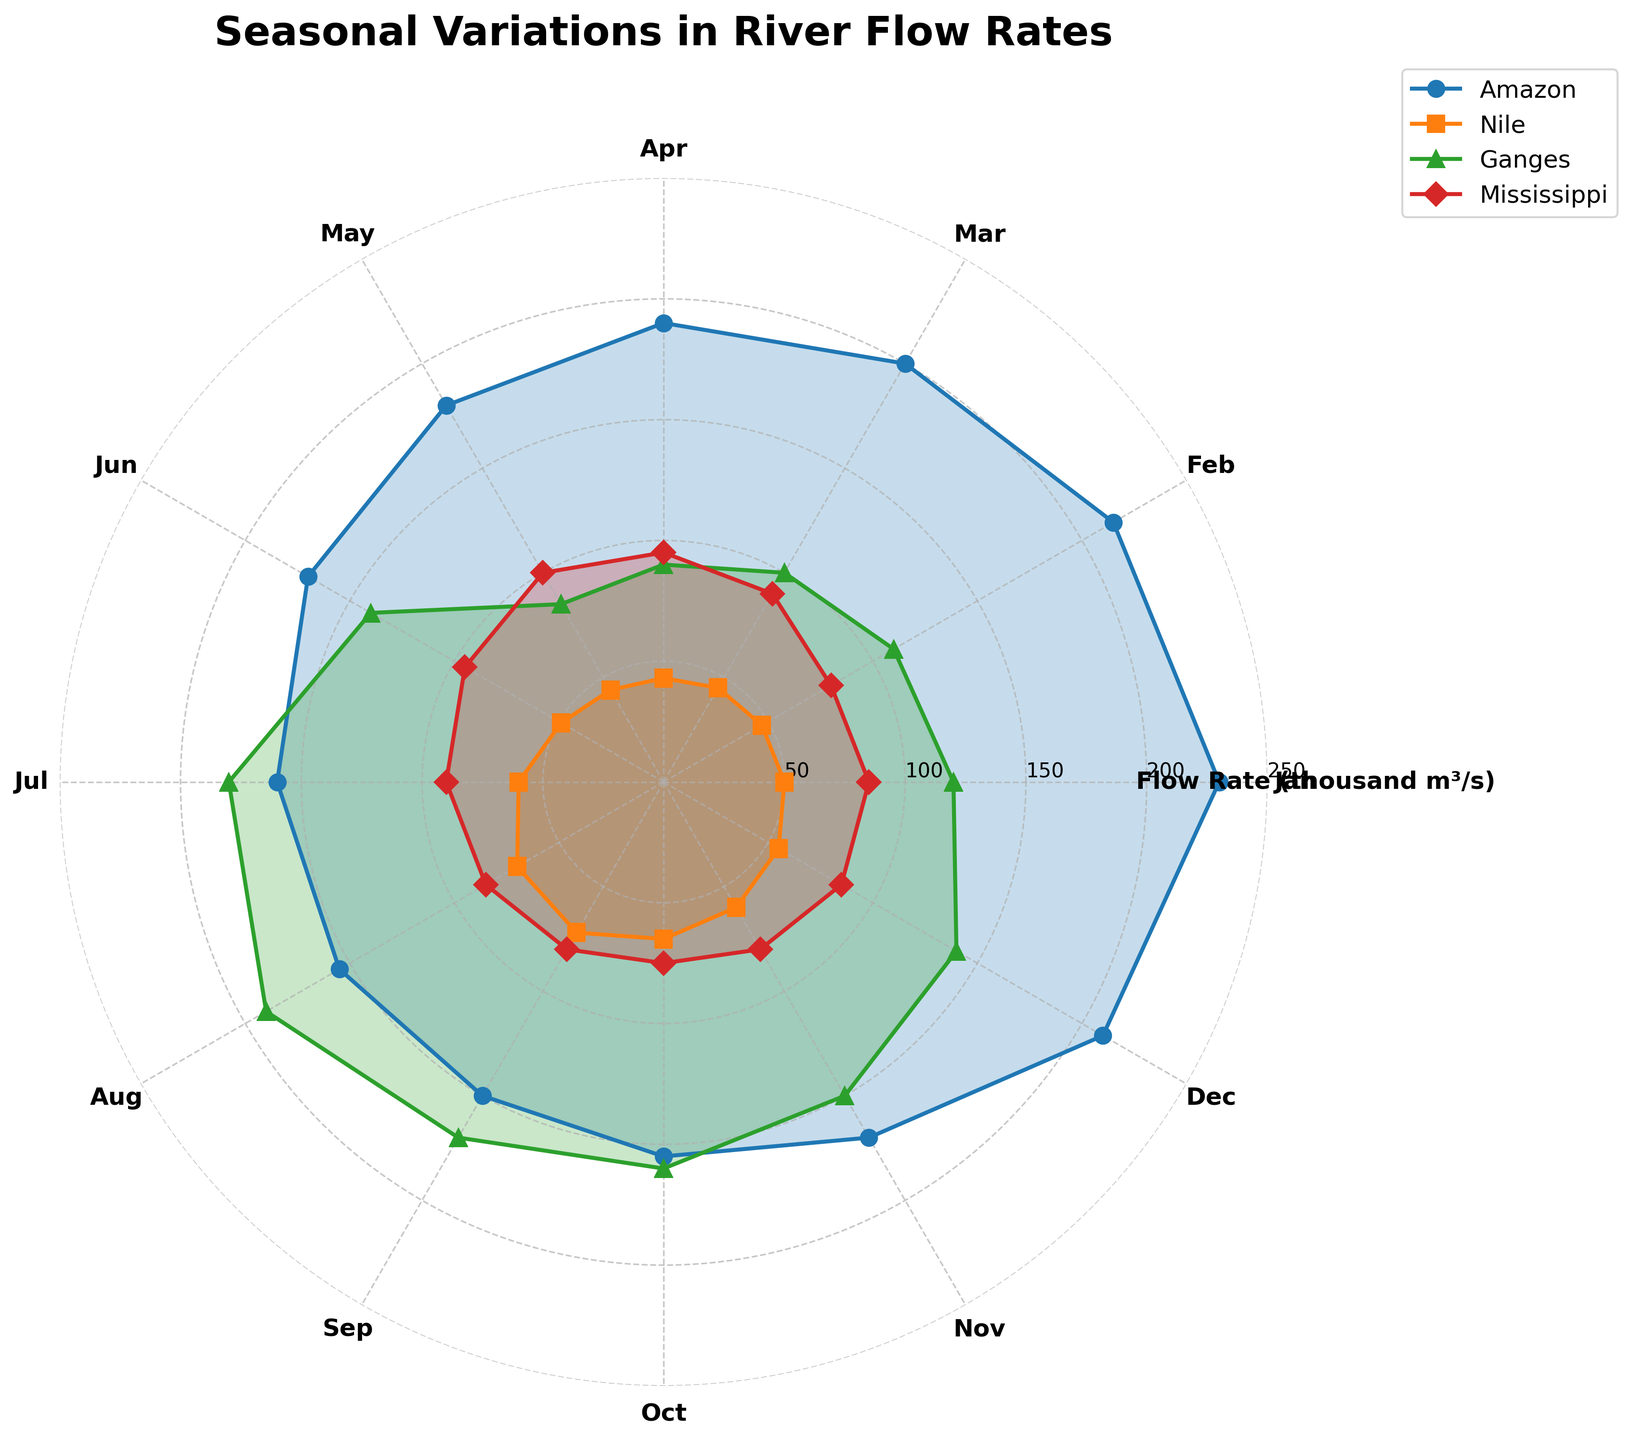What's the title of the figure? The title is displayed at the top of the figure, usually in larger and bold text.
Answer: Seasonal Variations in River Flow Rates How many rivers are compared in the chart? Each river is represented by a distinct color and line pattern on the polar chart. By counting the lines and the legend entries, one can determine the number of rivers.
Answer: 4 What color represents the Mississippi River? By looking at the legend, which maps each river to a specific color, we can see which color corresponds to the Mississippi River.
Answer: Blue In which month does the Nile River have its highest flow rate? Examine the polar plot for the Nile River's line and identify the month corresponding to its maximum point on the radial axis.
Answer: September Which river has the most pronounced seasonal variation in flow rate? Seasonal variation can be determined by looking at the spread of the data points on the polar chart; the river with the most significant difference between its maximum and minimum flow rates will have the most pronounced variation.
Answer: Amazon During which months is the flow rate of the Amazon River decreasing? Observe the polar plot for the Amazon River, and follow the flow rate values from month to month, identifying the period during which the values decrease continuously.
Answer: January to September How does the flow rate of the Ganges River in January compare to that in July? Compare the positions of the data points for the Ganges River in January and July on the polar chart to see which flow rate is higher.
Answer: January is lower than July What is the flow rate range for the Mississippi River throughout the year? By analyzing the highest and lowest points for the Mississippi River on the polar chart, we can determine the range of its flow rates.
Answer: 75,000 to 100,000 thousand m³/s Which river shows the least variation in flow rate across the months? The river with the least variation will have the most consistent or smallest changes in flow rate values across the months on the polar chart.
Answer: Mississippi In which month does the Ganges River experience a sharp increase in flow rate? Identify the month where there is a steep upward slope in the polar plot line for the Ganges River, which signifies a sharp increase in flow rate.
Answer: June 